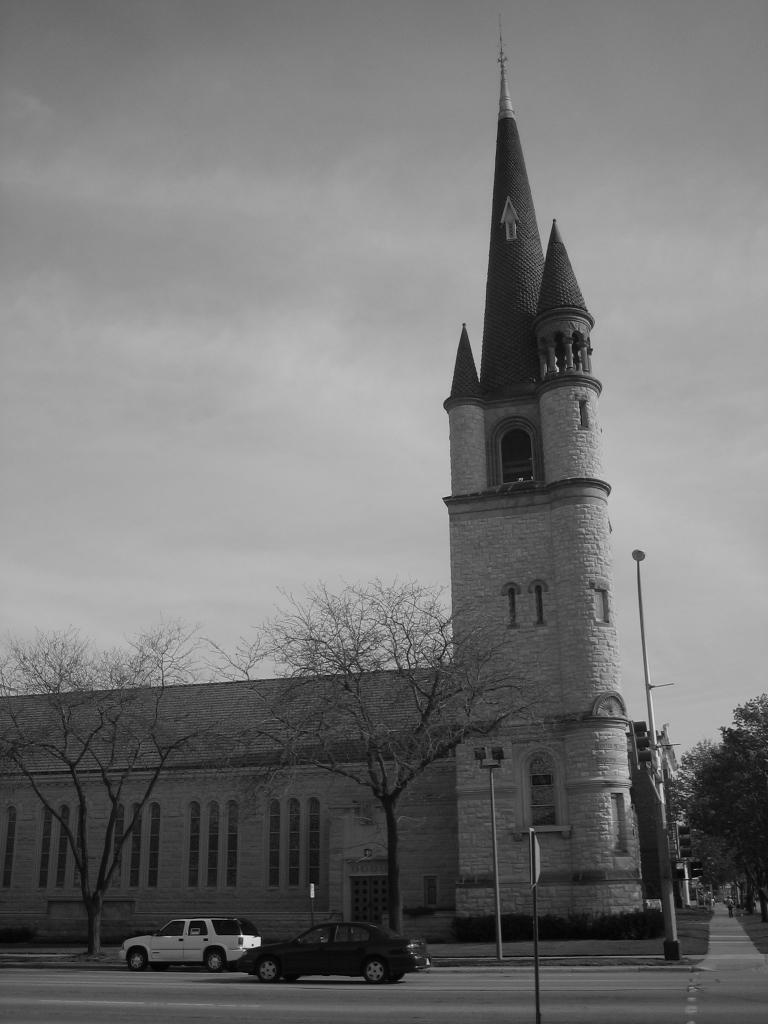What type of structure is present in the image? There is a building in the image. What can be seen on the road in the image? There are two vehicles on the road in the image. What objects are present in the image that are used for support or guidance? There are poles in the image. What type of vegetation is visible in the image? There are trees in the image. What is used for displaying information or advertisements in the image? There is a signboard in the image. What is visible in the background of the image? The sky is visible in the image. What type of yarn is being used to create the building in the image? There is no yarn present in the image; the building is a solid structure. How does the light affect the appearance of the vehicles in the image? The image does not provide information about the lighting conditions, so it is not possible to determine how the light affects the appearance of the vehicles. 